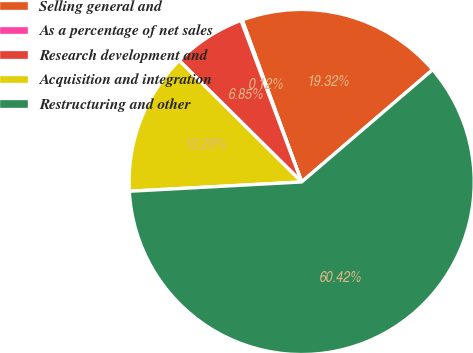Convert chart. <chart><loc_0><loc_0><loc_500><loc_500><pie_chart><fcel>Selling general and<fcel>As a percentage of net sales<fcel>Research development and<fcel>Acquisition and integration<fcel>Restructuring and other<nl><fcel>19.32%<fcel>0.12%<fcel>6.85%<fcel>13.29%<fcel>60.42%<nl></chart> 